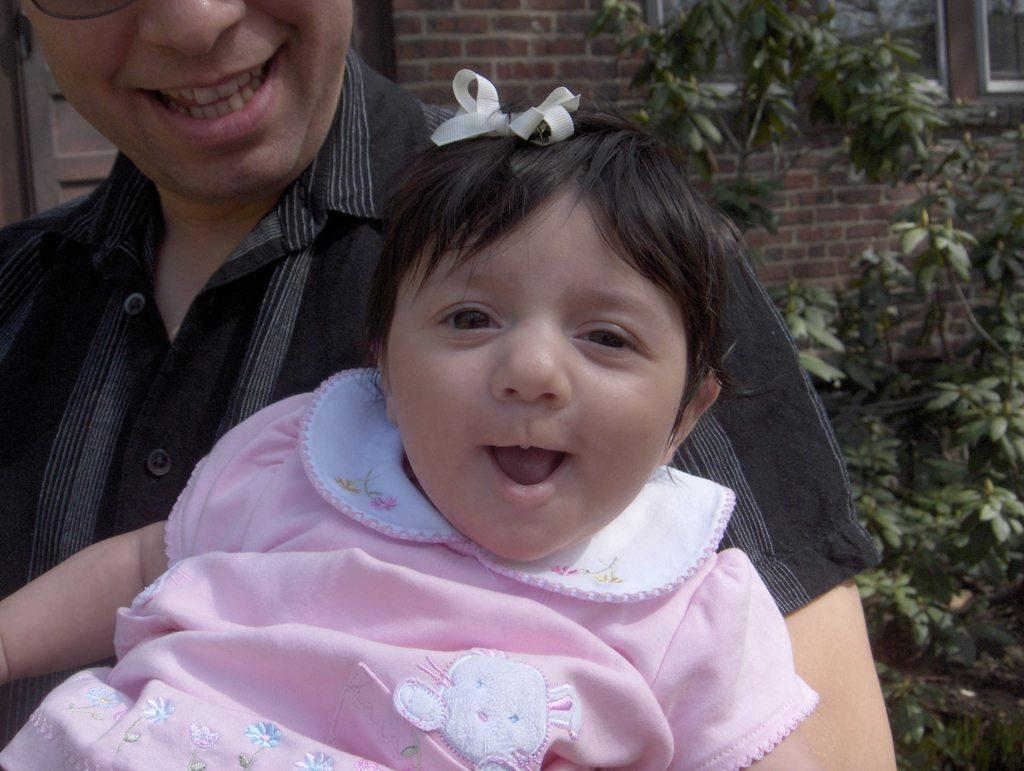What is the person in the image doing with the baby? The person is holding a baby in the image. How does the baby appear to be feeling? The baby is smiling in the image. What can be seen behind the person holding the baby? There are plants behind the person. What is located behind the plants? There is a wall and windows visible behind the plants. What type of drum can be heard playing in the background of the image? There is no drum present or audible in the image; it is a still photograph. 